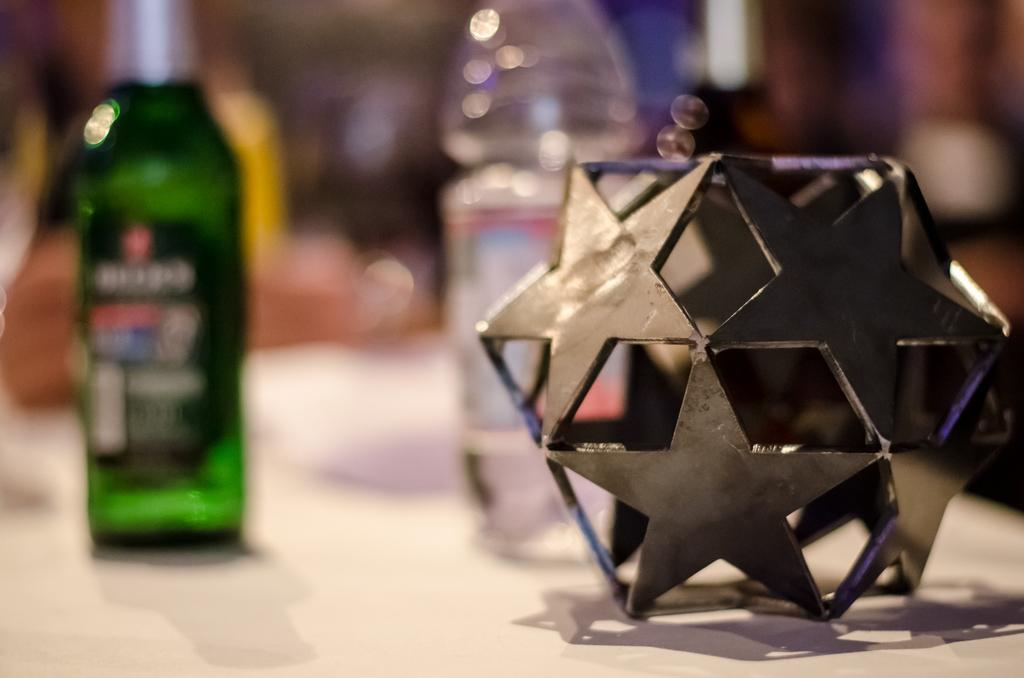What piece of furniture is present in the image? There is a table in the image. What items can be seen on the table? There are two bottles and a product on the table. How many frogs are sitting on the table in the image? There are no frogs present in the image. What is the size of the product on the table in the image? The size of the product cannot be determined from the image alone. 